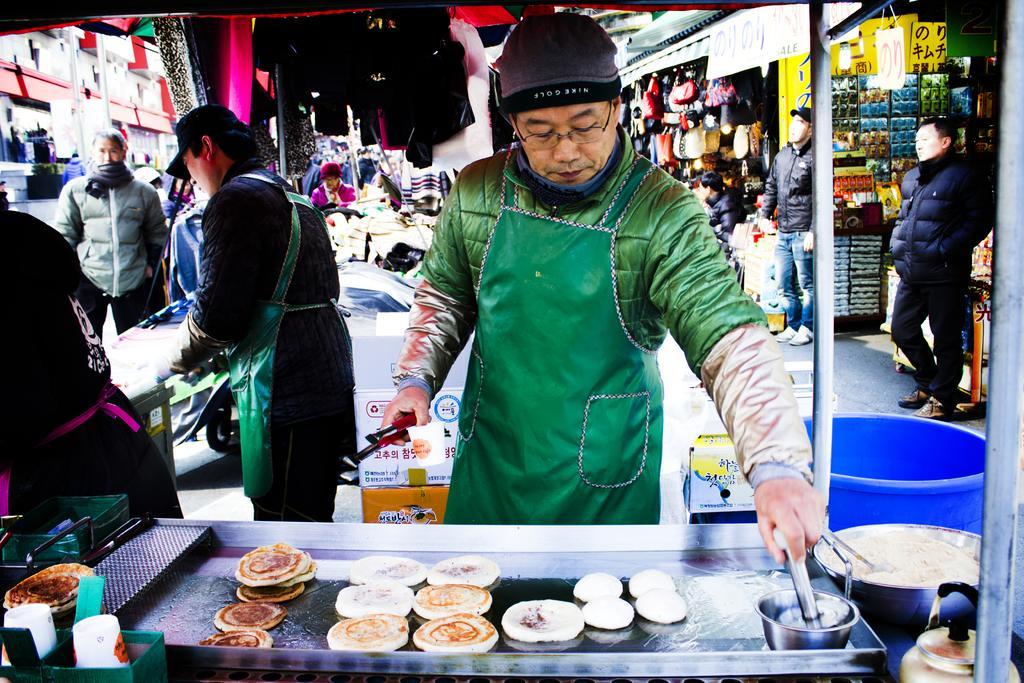Describe this image in one or two sentences. In this image there is a tray, in that tray there is a food item, behind the tray there are people standing, in the background there are shops in that shows there are few objects and people standing near the shops. 